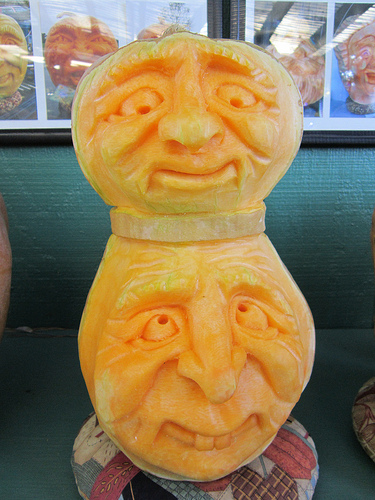<image>
Is there a sculpture in front of the wall? Yes. The sculpture is positioned in front of the wall, appearing closer to the camera viewpoint. Is the statue above the statue smiling? Yes. The statue is positioned above the statue smiling in the vertical space, higher up in the scene. 